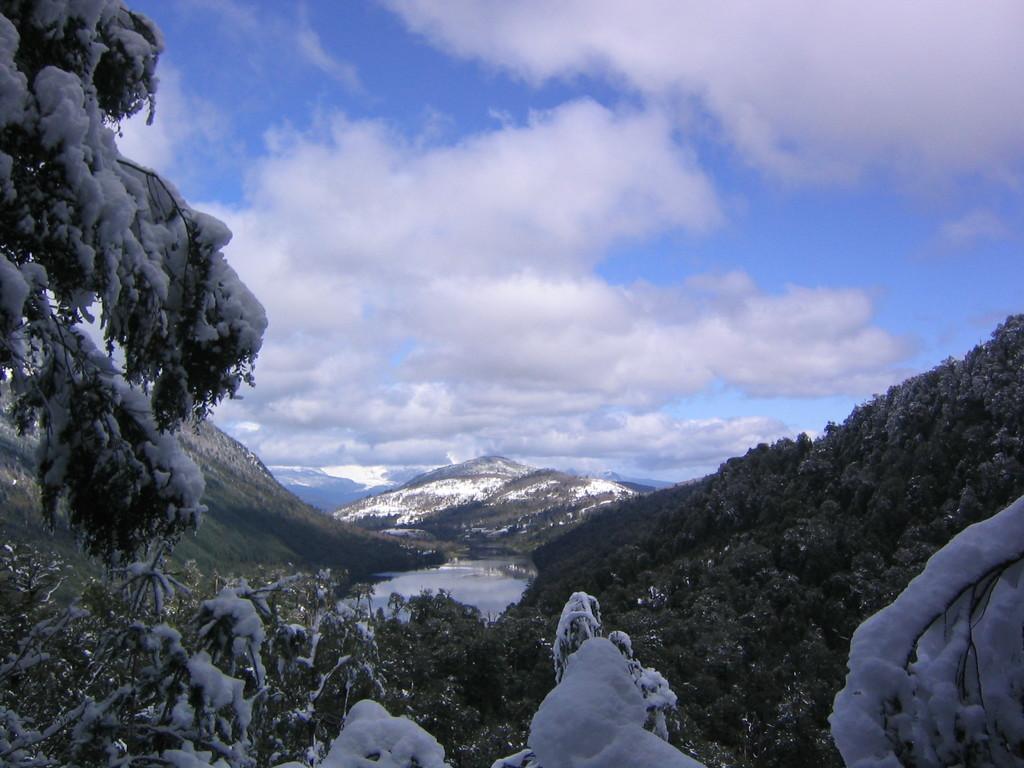Could you give a brief overview of what you see in this image? In this image I can see few trees which are green in color and on them I can see the snow which is white in color. In the background I can see the water, few mountains, few trees and some snow on the mountains and the sky. 